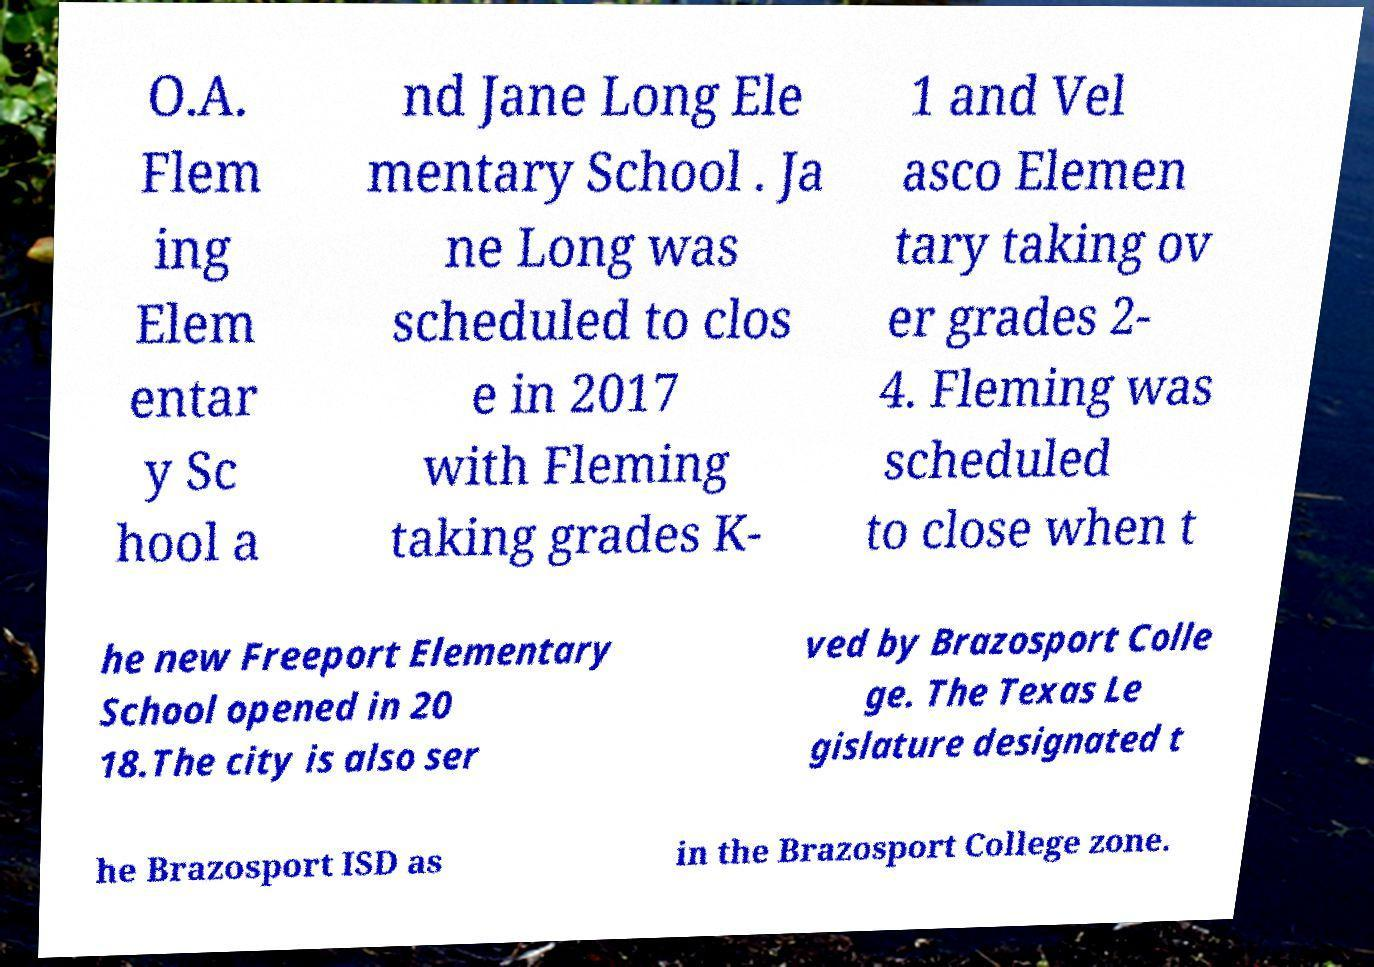Can you read and provide the text displayed in the image?This photo seems to have some interesting text. Can you extract and type it out for me? O.A. Flem ing Elem entar y Sc hool a nd Jane Long Ele mentary School . Ja ne Long was scheduled to clos e in 2017 with Fleming taking grades K- 1 and Vel asco Elemen tary taking ov er grades 2- 4. Fleming was scheduled to close when t he new Freeport Elementary School opened in 20 18.The city is also ser ved by Brazosport Colle ge. The Texas Le gislature designated t he Brazosport ISD as in the Brazosport College zone. 